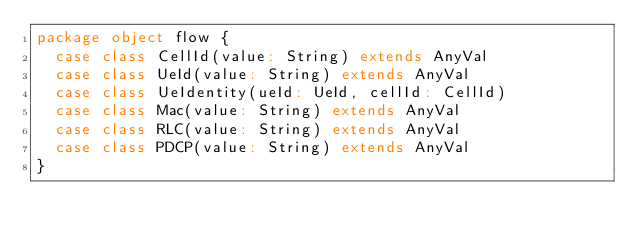<code> <loc_0><loc_0><loc_500><loc_500><_Scala_>package object flow {
  case class CellId(value: String) extends AnyVal
  case class UeId(value: String) extends AnyVal
  case class UeIdentity(ueId: UeId, cellId: CellId)
  case class Mac(value: String) extends AnyVal
  case class RLC(value: String) extends AnyVal
  case class PDCP(value: String) extends AnyVal
}
</code> 